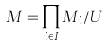<formula> <loc_0><loc_0><loc_500><loc_500>M = \prod _ { i \in I } M _ { i } / U</formula> 